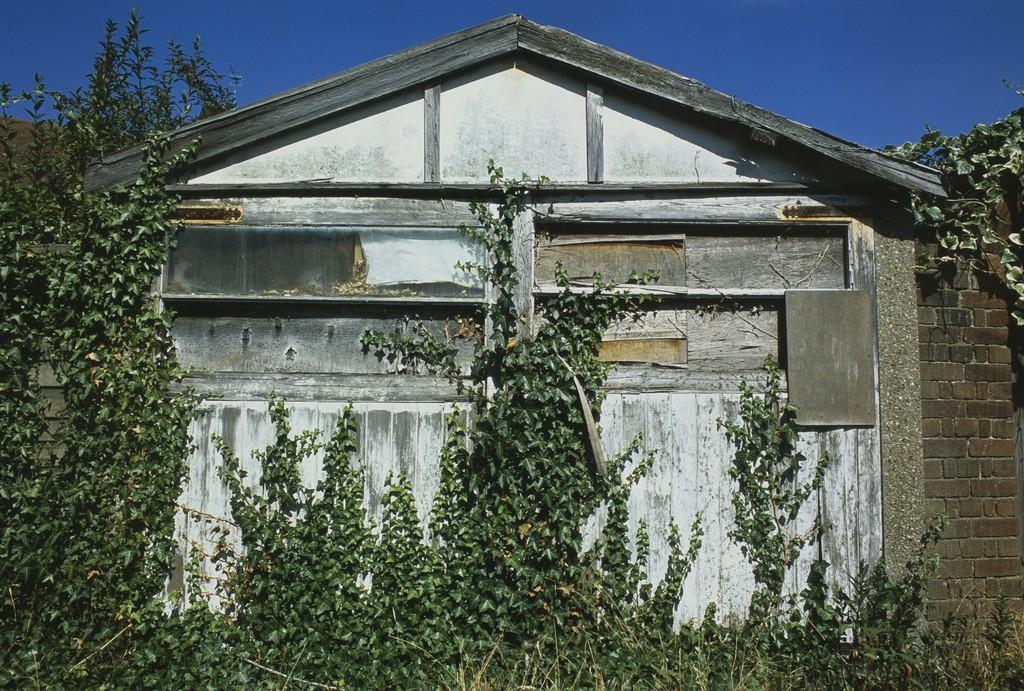What type of structure is present in the image? There is a house in the image. What else can be seen in the image besides the house? There is a wall, the sky, trees, and plants visible in the image. What type of button can be seen on the attraction in the image? There is no attraction or button present in the image. What time of day is it in the image, considering the presence of the afternoon? The provided facts do not mention the time of day or the presence of an afternoon, so it cannot be determined from the image. 